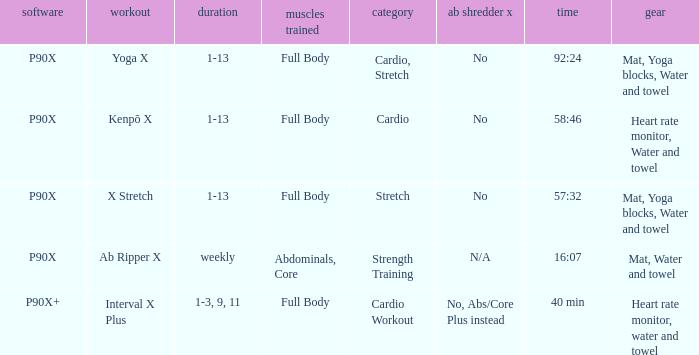What is the ab ripper x when the length is 92:24? No. 